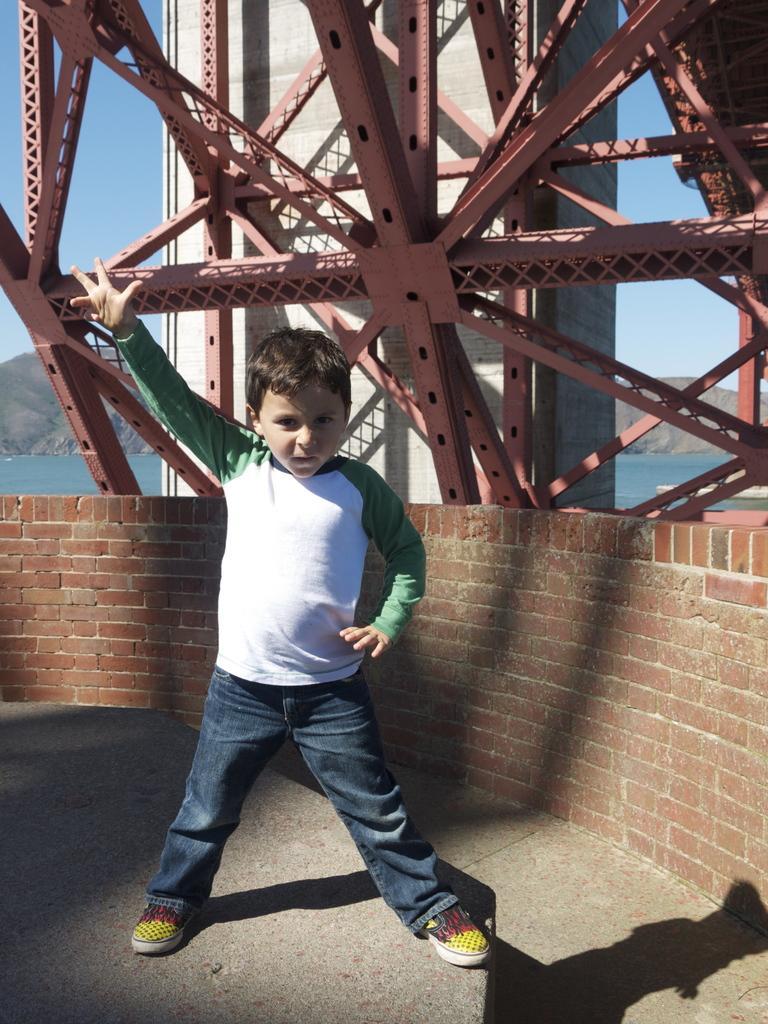Could you give a brief overview of what you see in this image? In this image in the center there is one boy who is standing and in the background there is a wall and tower and also some mountains. In the center there is a beach, at the top of the image there is sky and at the bottom there is a walkway. 